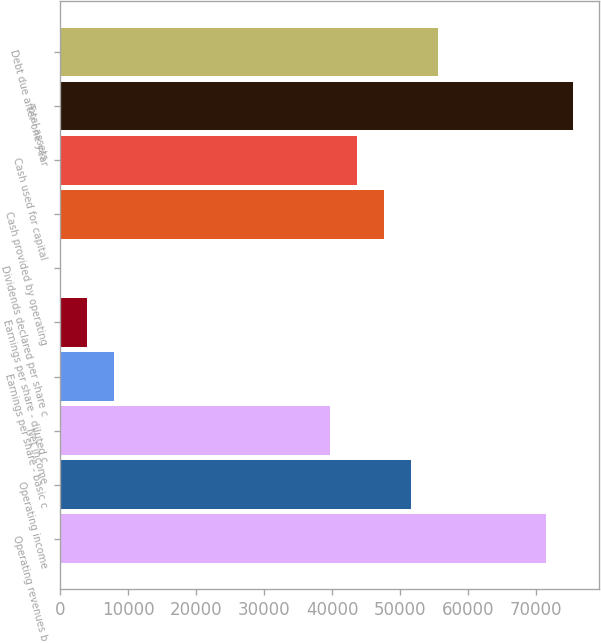Convert chart. <chart><loc_0><loc_0><loc_500><loc_500><bar_chart><fcel>Operating revenues b<fcel>Operating income<fcel>Net income<fcel>Earnings per share - basic c<fcel>Earnings per share - diluted c<fcel>Dividends declared per share c<fcel>Cash provided by operating<fcel>Cash used for capital<fcel>Total assets<fcel>Debt due after one year<nl><fcel>71498.8<fcel>51638.3<fcel>39722<fcel>7945.18<fcel>3973.08<fcel>0.98<fcel>47666.2<fcel>43694.1<fcel>75470.9<fcel>55610.4<nl></chart> 